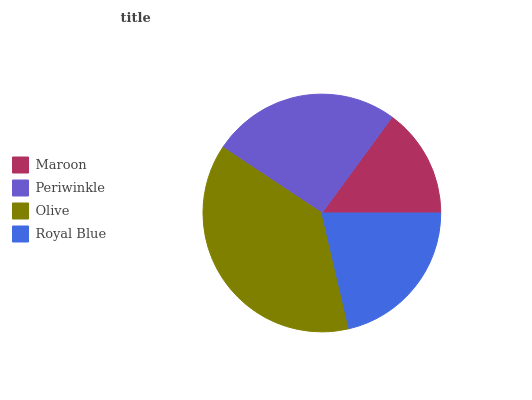Is Maroon the minimum?
Answer yes or no. Yes. Is Olive the maximum?
Answer yes or no. Yes. Is Periwinkle the minimum?
Answer yes or no. No. Is Periwinkle the maximum?
Answer yes or no. No. Is Periwinkle greater than Maroon?
Answer yes or no. Yes. Is Maroon less than Periwinkle?
Answer yes or no. Yes. Is Maroon greater than Periwinkle?
Answer yes or no. No. Is Periwinkle less than Maroon?
Answer yes or no. No. Is Periwinkle the high median?
Answer yes or no. Yes. Is Royal Blue the low median?
Answer yes or no. Yes. Is Olive the high median?
Answer yes or no. No. Is Periwinkle the low median?
Answer yes or no. No. 